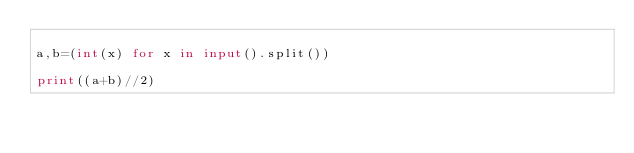Convert code to text. <code><loc_0><loc_0><loc_500><loc_500><_Python_>
a,b=(int(x) for x in input().split())

print((a+b)//2)
</code> 